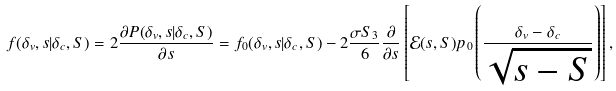Convert formula to latex. <formula><loc_0><loc_0><loc_500><loc_500>f ( \delta _ { v } , s | \delta _ { c } , S ) = 2 \frac { \partial P ( \delta _ { v } , s | \delta _ { c } , S ) } { \partial s } = f _ { 0 } ( \delta _ { v } , s | \delta _ { c } , S ) - 2 \frac { \sigma S _ { 3 } } { 6 } \frac { \partial } { \partial s } \left [ \mathcal { E } ( s , S ) p _ { 0 } \left ( \frac { \delta _ { v } - \delta _ { c } } { \sqrt { s - S } } \right ) \right ] ,</formula> 